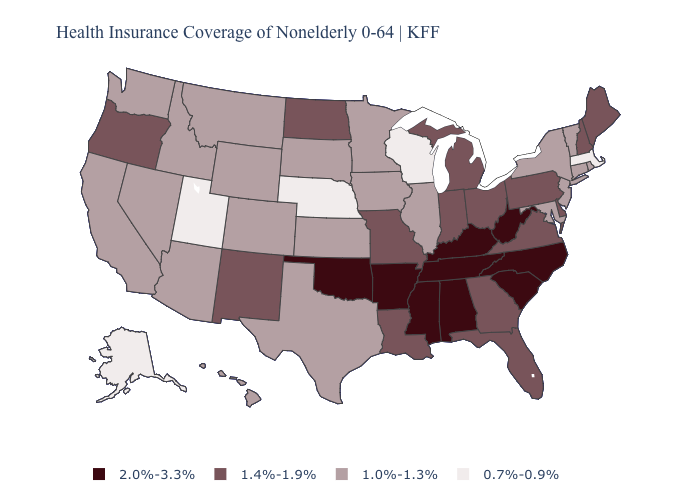Name the states that have a value in the range 2.0%-3.3%?
Concise answer only. Alabama, Arkansas, Kentucky, Mississippi, North Carolina, Oklahoma, South Carolina, Tennessee, West Virginia. What is the value of Connecticut?
Quick response, please. 1.0%-1.3%. What is the lowest value in states that border Ohio?
Concise answer only. 1.4%-1.9%. What is the value of Michigan?
Quick response, please. 1.4%-1.9%. Name the states that have a value in the range 2.0%-3.3%?
Be succinct. Alabama, Arkansas, Kentucky, Mississippi, North Carolina, Oklahoma, South Carolina, Tennessee, West Virginia. What is the value of Illinois?
Be succinct. 1.0%-1.3%. Does North Carolina have the highest value in the USA?
Answer briefly. Yes. Which states have the lowest value in the USA?
Concise answer only. Alaska, Massachusetts, Nebraska, Utah, Wisconsin. Does the map have missing data?
Keep it brief. No. Name the states that have a value in the range 0.7%-0.9%?
Answer briefly. Alaska, Massachusetts, Nebraska, Utah, Wisconsin. Which states have the lowest value in the Northeast?
Keep it brief. Massachusetts. Does West Virginia have the lowest value in the USA?
Concise answer only. No. Name the states that have a value in the range 0.7%-0.9%?
Quick response, please. Alaska, Massachusetts, Nebraska, Utah, Wisconsin. Among the states that border Virginia , which have the highest value?
Answer briefly. Kentucky, North Carolina, Tennessee, West Virginia. 